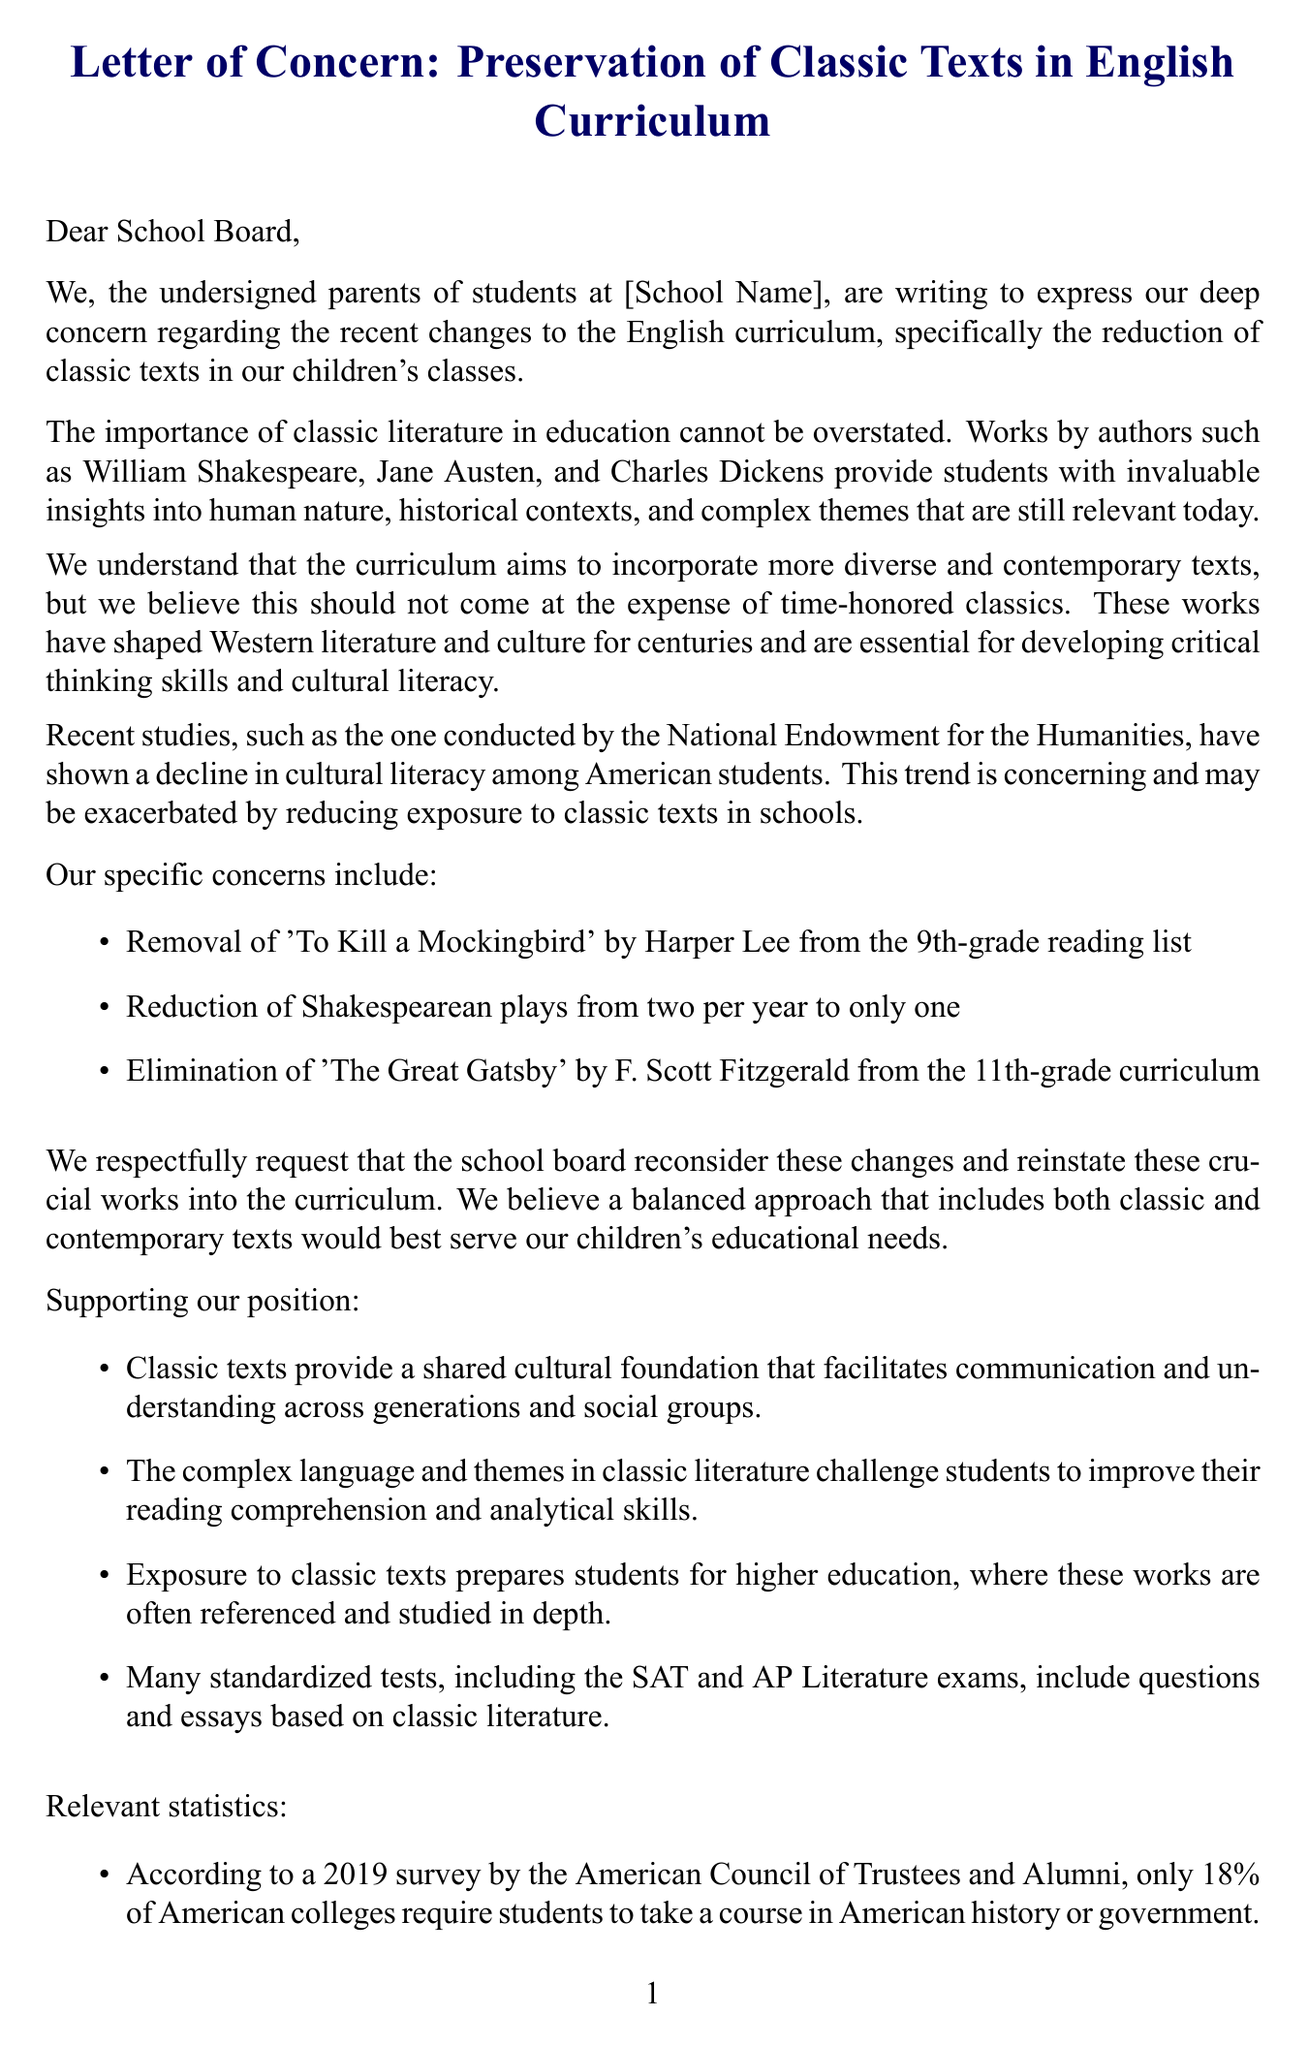What is the title of the letter? The title of the letter is indicated at the beginning of the document and is focused on the main concern addressed within.
Answer: Letter of Concern: Preservation of Classic Texts in English Curriculum Who is the letter addressed to? The letter opens with a salutation directed towards the school board or principal, highlighting the intended recipients.
Answer: School Board What work by Jane Austen is referenced? The letter highlights the significance of classic literature, mentioning specific authors, including Jane Austen, to emphasize its importance.
Answer: Not specified Which classic text was removed from the 9th-grade reading list? The letter states specific texts that were removed or reduced, asking for reinstatement of classic works.
Answer: To Kill a Mockingbird What percentage of American colleges require a course in history or government? The document refers to statistics to support the argument for retaining classic texts in the curriculum.
Answer: 18% What are parents requesting regarding the curriculum? The main request of the letter is outlined clearly in the concluding section, summarizing the parents' proposal.
Answer: Reconsider these changes Which study shows a decline in cultural literacy? The document mentions a study conducted by a reputable organization to substantiate claims made regarding educational trends.
Answer: National Endowment for the Humanities Who provided a supportive quote from Yale University? The letter includes citations from experts in the field of humanities to provide authoritative backing for the parents' views.
Answer: Dr. Harold Bloom What is one proposed alternative to the reduced classic texts? The letter suggests several alternatives for the curriculum that would balance classic and contemporary literature.
Answer: Implement a rotating curriculum 